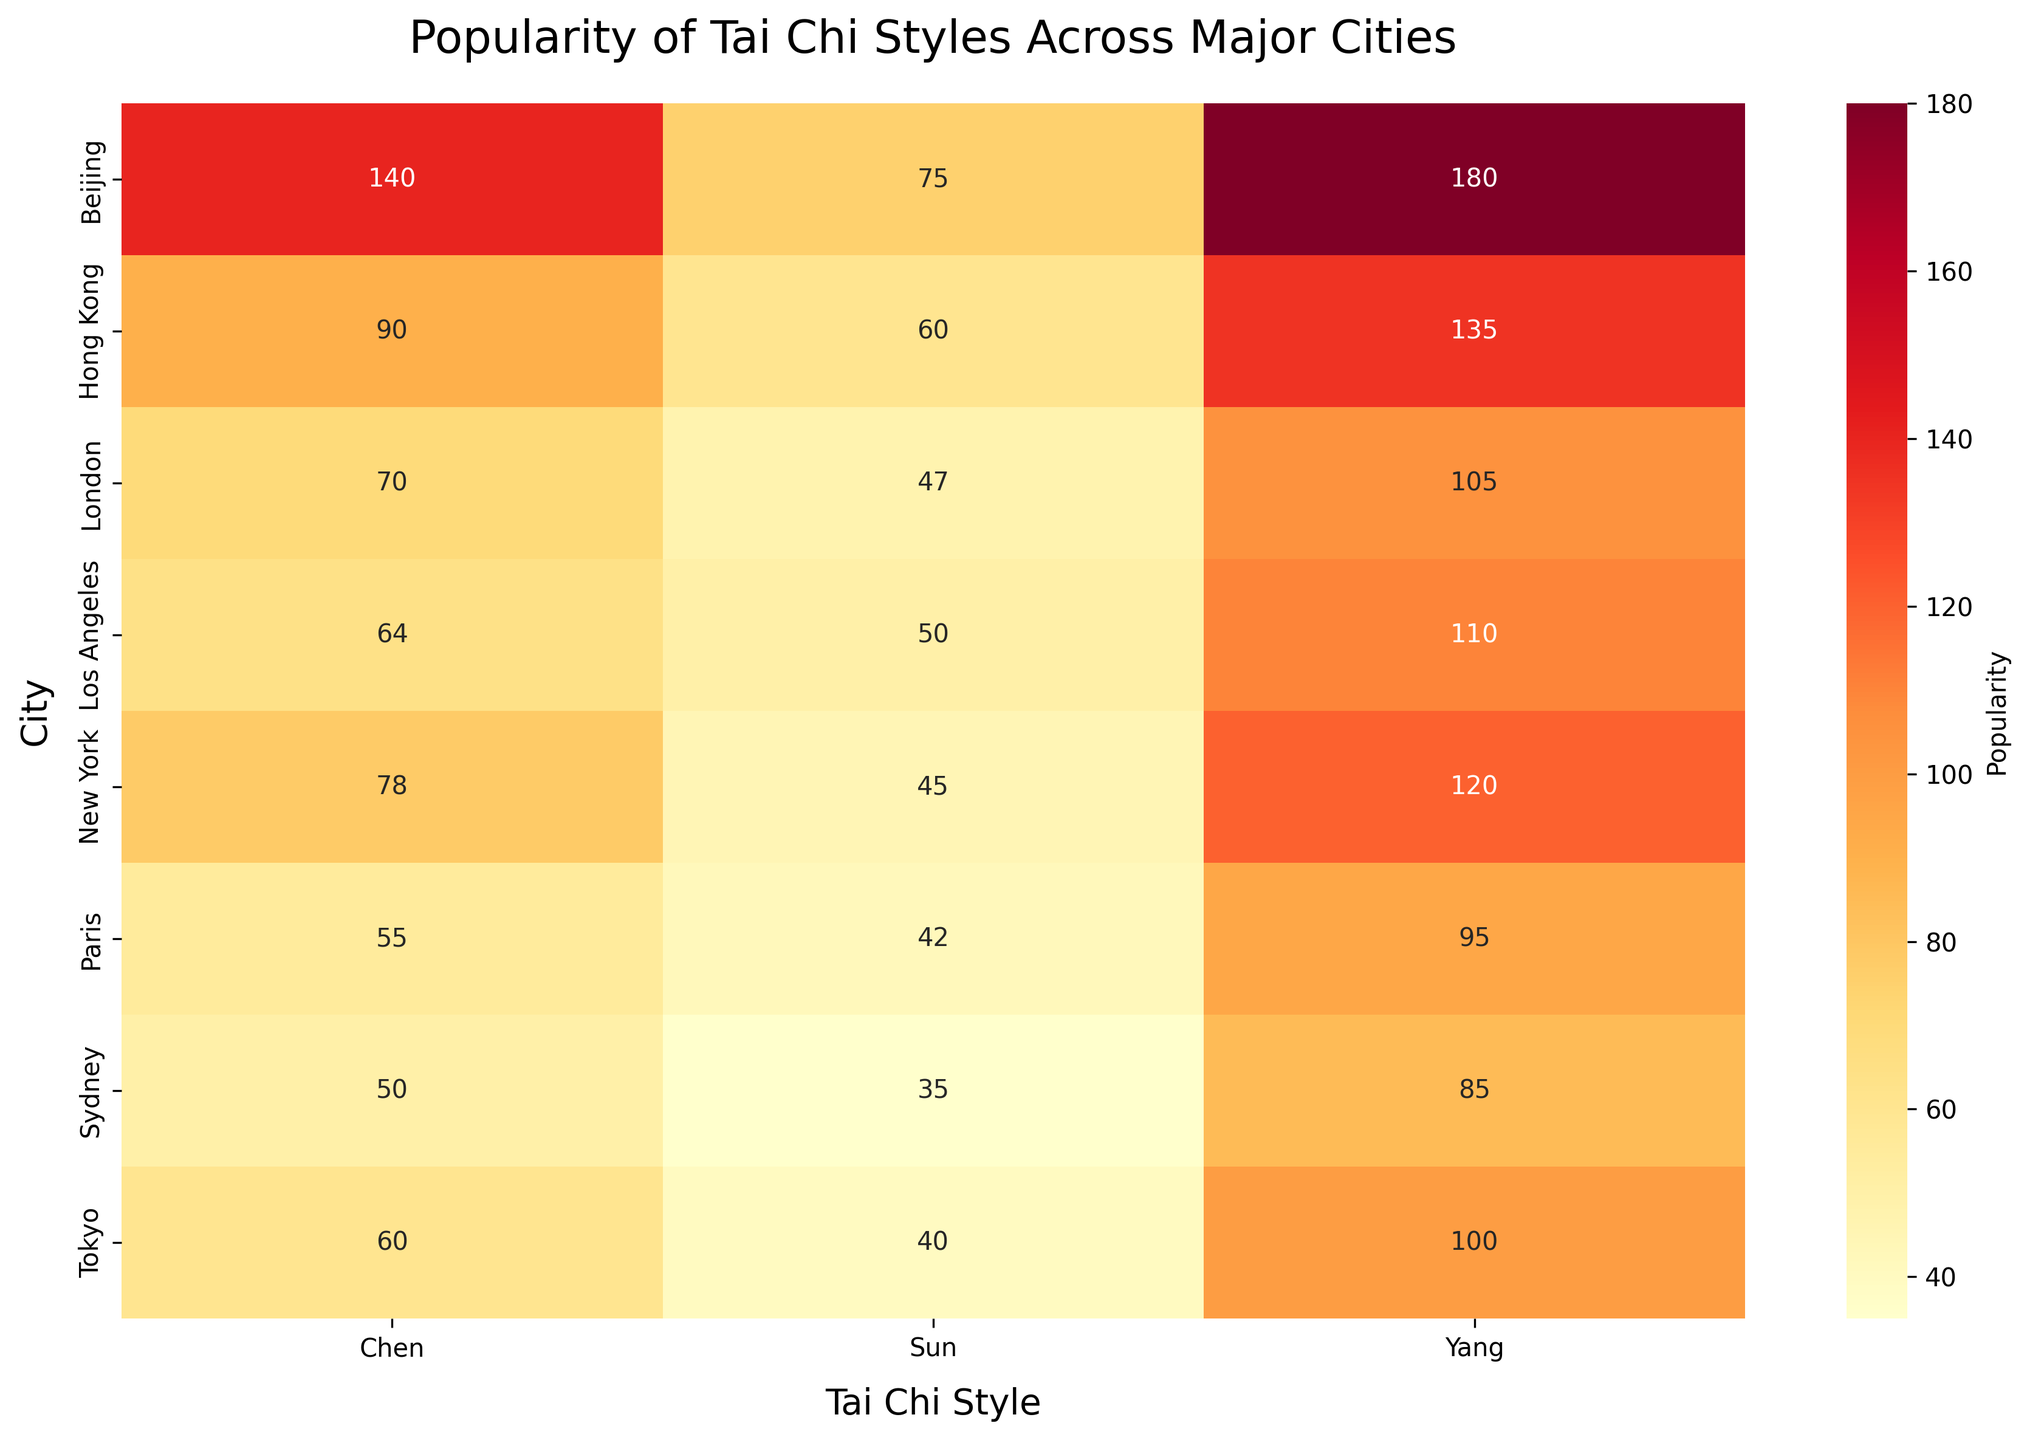What's the most popular Tai Chi style in Beijing? Check the values corresponding to Beijing for each style and identify the maximum. Chen: 140, Yang: 180, Sun: 75. Yang has the highest value.
Answer: Yang What's the least popular city for Yang style Tai Chi? Compare the values for Yang across all cities: New York: 120, Los Angeles: 110, London: 105, Paris: 95, Beijing: 180, Hong Kong: 135, Tokyo: 100, Sydney: 85. The smallest value is in Sydney.
Answer: Sydney What is the total popularity of Sun style across all the cities? Sum the values for Sun style in each city: New York: 45, Los Angeles: 50, London: 47, Paris: 42, Beijing: 75, Hong Kong: 60, Tokyo: 40, Sydney: 35. Summing these gives 45 + 50 + 47 + 42 + 75 + 60 + 40 + 35 = 394.
Answer: 394 Which city has the highest overall popularity for Tai Chi styles combined? For each city, sum the values of all styles: New York: 78 + 120 + 45 = 243, Los Angeles: 64 + 110 + 50 = 224, London: 70 + 105 + 47 = 222, Paris: 55 + 95 + 42 = 192, Beijing: 140 + 180 + 75 = 395, Hong Kong: 90 + 135 + 60 = 285, Tokyo: 60 + 100 + 40 = 200, Sydney: 50 + 85 + 35 = 170. Beijing has the highest combined total of 395.
Answer: Beijing Which style is more popular in Hong Kong, Chen or Yang? Compare the values for Chen and Yang in Hong Kong. Chen: 90, Yang: 135. Yang has a higher value.
Answer: Yang What is the average popularity of the Chen style across all cities? Calculate the average by summing the Chen values and dividing by the number of cities: (78 + 64 + 70 + 55 + 140 + 90 + 60 + 50) / 8 = 607 / 8 = 75.875, rounded up ≈ 76.
Answer: 76 Which city has a higher popularity for Sun style, Los Angeles or London? Compare the Sun values in Los Angeles and London. Los Angeles: 50, London: 47. Los Angeles has a higher value.
Answer: Los Angeles What is the difference in popularity between the most and least popular Tai Chi styles in Paris? Identify the maximum and minimum values in Paris. Yang: 95 (max), Sun: 42 (min). Difference: 95 - 42 = 53.
Answer: 53 Which city has a more balanced popularity across different Tai Chi styles, Sydney or Paris? Compare the range (max-min) for each city's styles: Sydney: max=85 (Yang), min=35 (Sun), range=85-35=50. Paris: max=95 (Yang), min=42 (Sun), range=95-42=53. A smaller range indicates more balance, so Sydney has a more balanced popularity.
Answer: Sydney 